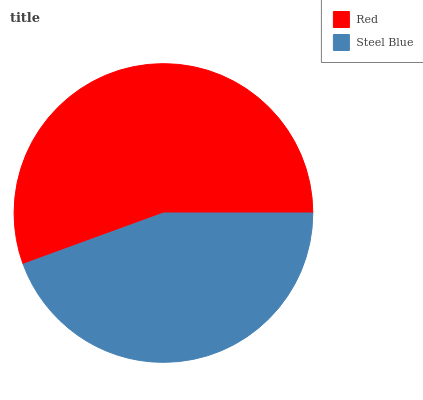Is Steel Blue the minimum?
Answer yes or no. Yes. Is Red the maximum?
Answer yes or no. Yes. Is Steel Blue the maximum?
Answer yes or no. No. Is Red greater than Steel Blue?
Answer yes or no. Yes. Is Steel Blue less than Red?
Answer yes or no. Yes. Is Steel Blue greater than Red?
Answer yes or no. No. Is Red less than Steel Blue?
Answer yes or no. No. Is Red the high median?
Answer yes or no. Yes. Is Steel Blue the low median?
Answer yes or no. Yes. Is Steel Blue the high median?
Answer yes or no. No. Is Red the low median?
Answer yes or no. No. 